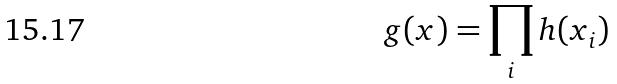<formula> <loc_0><loc_0><loc_500><loc_500>g ( x ) = \prod _ { i } h ( x _ { i } )</formula> 